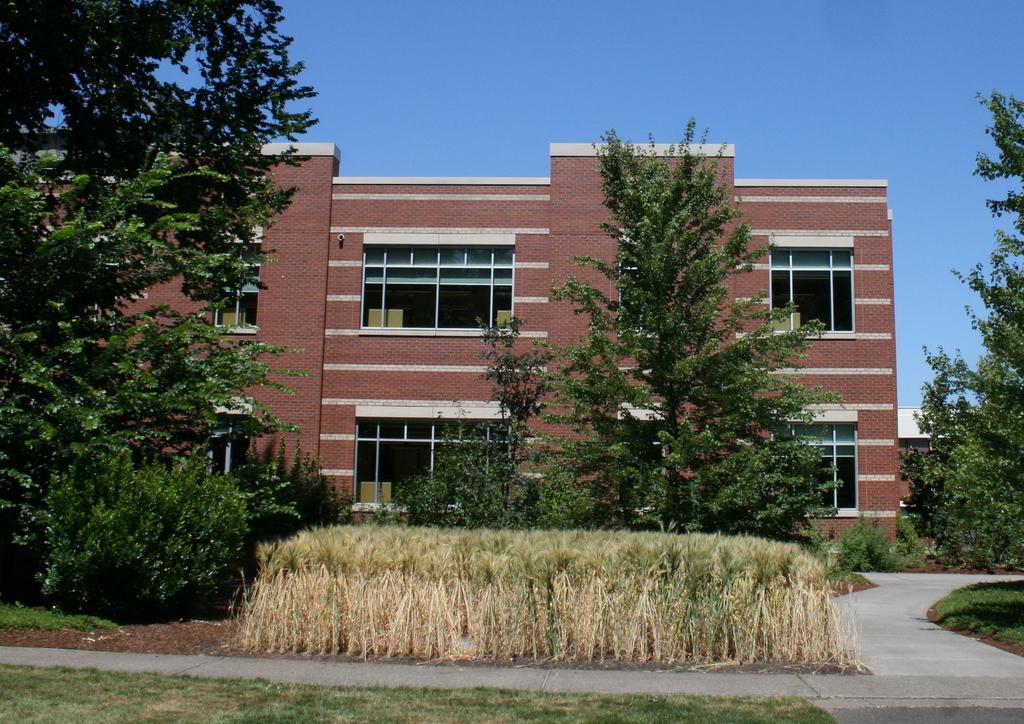Could you give a brief overview of what you see in this image? In the foreground of this image, there is the grass, path and the plants. In the background, there are trees, pavement, building and the sky. 